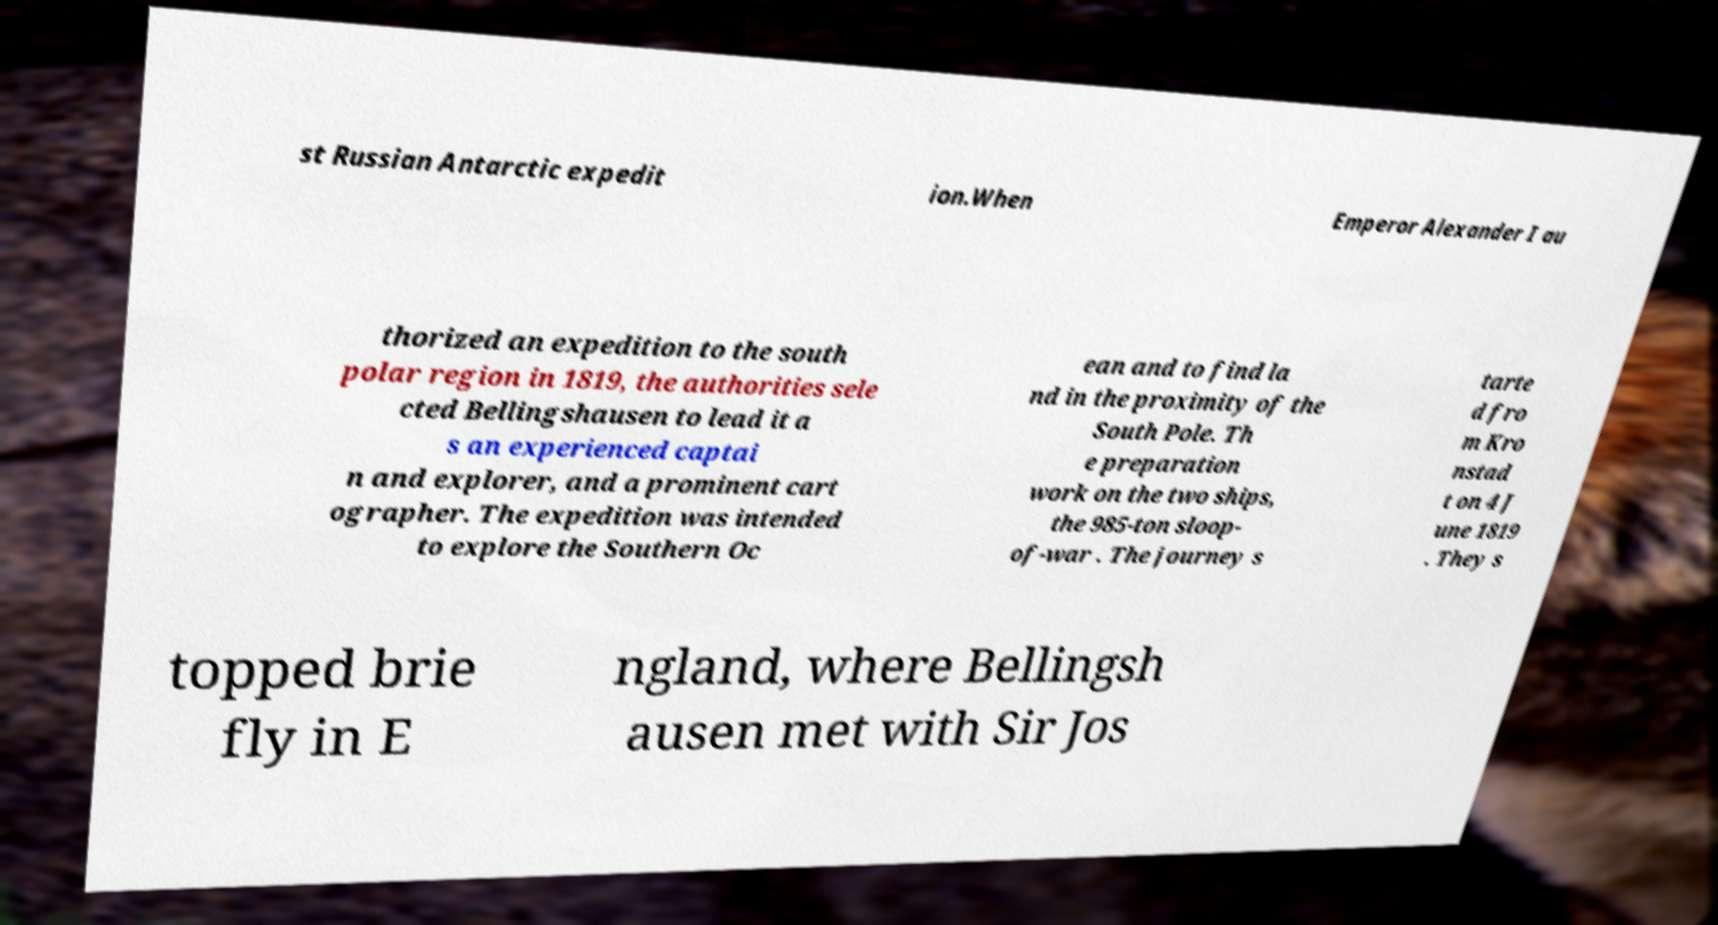Can you read and provide the text displayed in the image?This photo seems to have some interesting text. Can you extract and type it out for me? st Russian Antarctic expedit ion.When Emperor Alexander I au thorized an expedition to the south polar region in 1819, the authorities sele cted Bellingshausen to lead it a s an experienced captai n and explorer, and a prominent cart ographer. The expedition was intended to explore the Southern Oc ean and to find la nd in the proximity of the South Pole. Th e preparation work on the two ships, the 985-ton sloop- of-war . The journey s tarte d fro m Kro nstad t on 4 J une 1819 . They s topped brie fly in E ngland, where Bellingsh ausen met with Sir Jos 